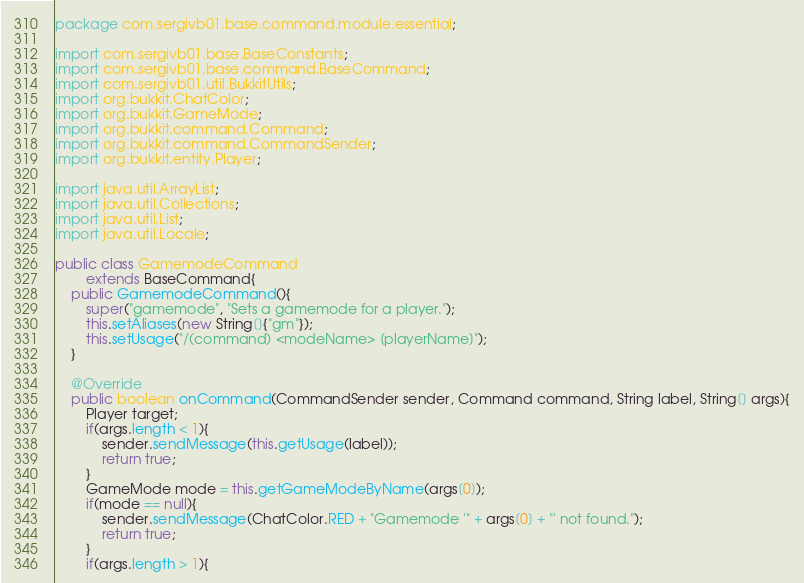<code> <loc_0><loc_0><loc_500><loc_500><_Java_>package com.sergivb01.base.command.module.essential;

import com.sergivb01.base.BaseConstants;
import com.sergivb01.base.command.BaseCommand;
import com.sergivb01.util.BukkitUtils;
import org.bukkit.ChatColor;
import org.bukkit.GameMode;
import org.bukkit.command.Command;
import org.bukkit.command.CommandSender;
import org.bukkit.entity.Player;

import java.util.ArrayList;
import java.util.Collections;
import java.util.List;
import java.util.Locale;

public class GamemodeCommand
		extends BaseCommand{
	public GamemodeCommand(){
		super("gamemode", "Sets a gamemode for a player.");
		this.setAliases(new String[]{"gm"});
		this.setUsage("/(command) <modeName> [playerName]");
	}

	@Override
	public boolean onCommand(CommandSender sender, Command command, String label, String[] args){
		Player target;
		if(args.length < 1){
			sender.sendMessage(this.getUsage(label));
			return true;
		}
		GameMode mode = this.getGameModeByName(args[0]);
		if(mode == null){
			sender.sendMessage(ChatColor.RED + "Gamemode '" + args[0] + "' not found.");
			return true;
		}
		if(args.length > 1){</code> 